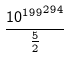<formula> <loc_0><loc_0><loc_500><loc_500>\frac { { 1 0 ^ { 1 9 9 } } ^ { 2 9 4 } } { \frac { 5 } { 2 } }</formula> 